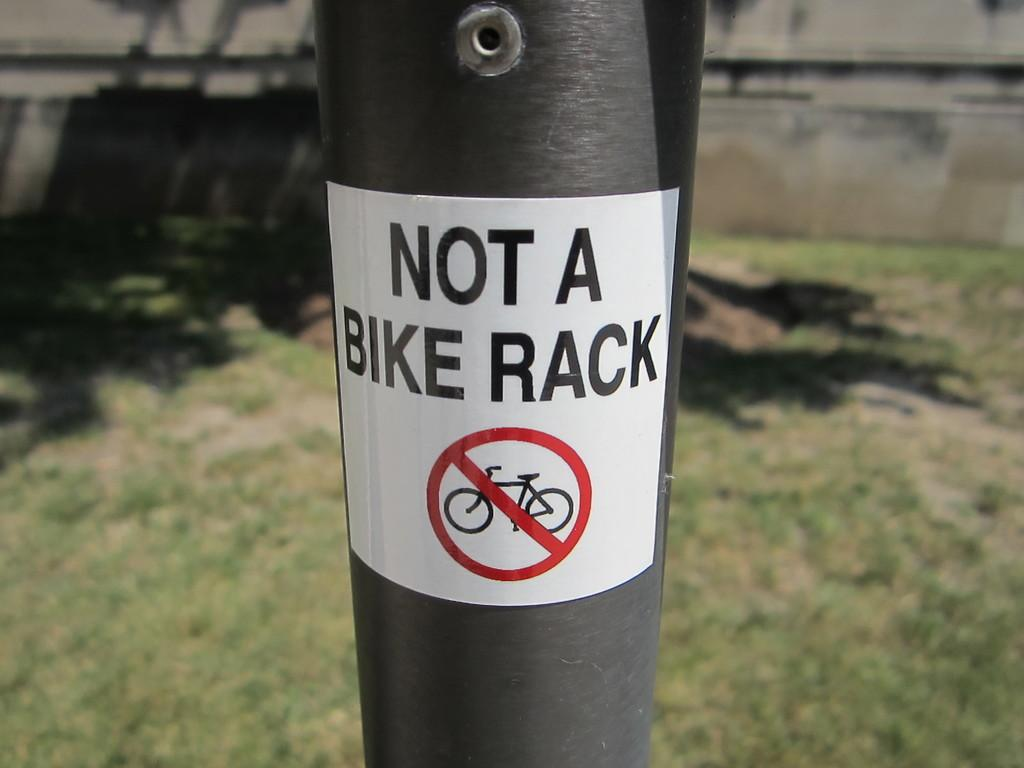What is attached to the pole in the image? There is a paper with text on the pole in the image. What can be seen in the background of the image? There is grass and a wall visible in the background of the image. How does the text on the paper affect the comfort of the people in the image? There is no information about people or their comfort in the image, so we cannot determine how the text on the paper affects them. 